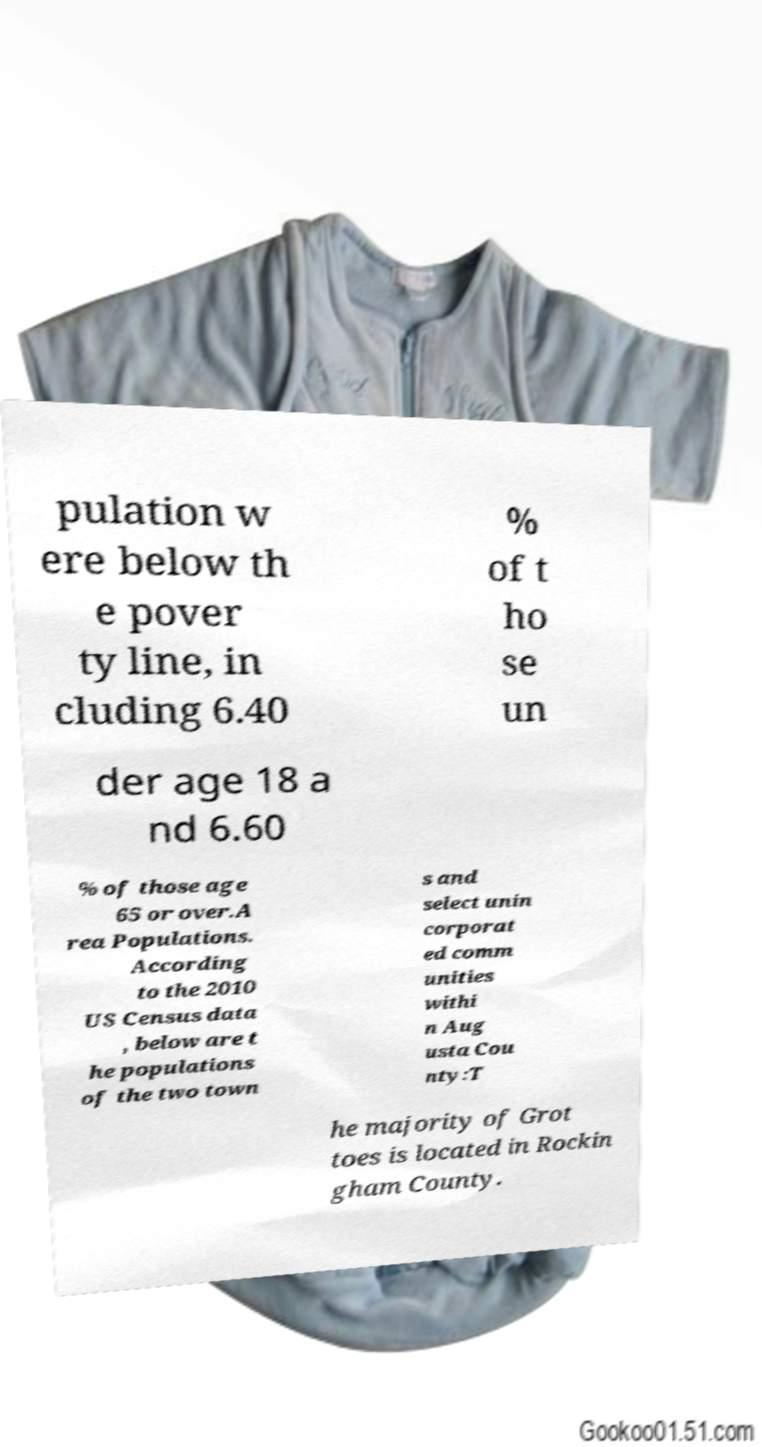For documentation purposes, I need the text within this image transcribed. Could you provide that? pulation w ere below th e pover ty line, in cluding 6.40 % of t ho se un der age 18 a nd 6.60 % of those age 65 or over.A rea Populations. According to the 2010 US Census data , below are t he populations of the two town s and select unin corporat ed comm unities withi n Aug usta Cou nty:T he majority of Grot toes is located in Rockin gham County. 